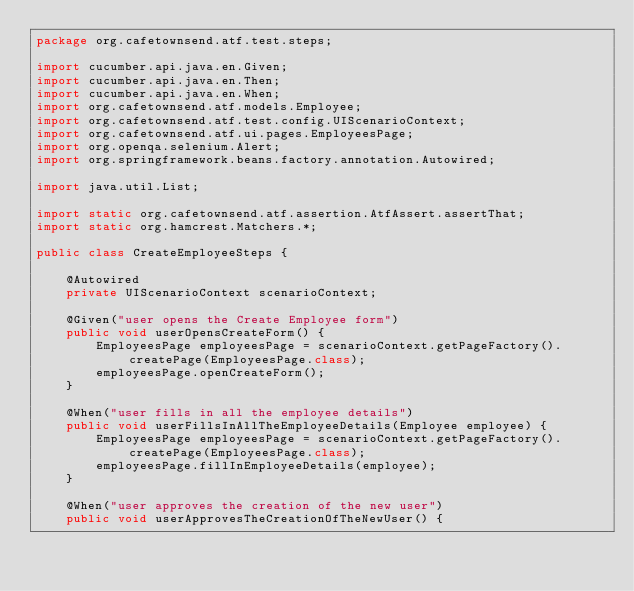Convert code to text. <code><loc_0><loc_0><loc_500><loc_500><_Java_>package org.cafetownsend.atf.test.steps;

import cucumber.api.java.en.Given;
import cucumber.api.java.en.Then;
import cucumber.api.java.en.When;
import org.cafetownsend.atf.models.Employee;
import org.cafetownsend.atf.test.config.UIScenarioContext;
import org.cafetownsend.atf.ui.pages.EmployeesPage;
import org.openqa.selenium.Alert;
import org.springframework.beans.factory.annotation.Autowired;

import java.util.List;

import static org.cafetownsend.atf.assertion.AtfAssert.assertThat;
import static org.hamcrest.Matchers.*;

public class CreateEmployeeSteps {

    @Autowired
    private UIScenarioContext scenarioContext;

    @Given("user opens the Create Employee form")
    public void userOpensCreateForm() {
        EmployeesPage employeesPage = scenarioContext.getPageFactory().createPage(EmployeesPage.class);
        employeesPage.openCreateForm();
    }

    @When("user fills in all the employee details")
    public void userFillsInAllTheEmployeeDetails(Employee employee) {
        EmployeesPage employeesPage = scenarioContext.getPageFactory().createPage(EmployeesPage.class);
        employeesPage.fillInEmployeeDetails(employee);
    }

    @When("user approves the creation of the new user")
    public void userApprovesTheCreationOfTheNewUser() {</code> 